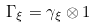<formula> <loc_0><loc_0><loc_500><loc_500>\Gamma _ { \xi } = \gamma _ { \xi } \otimes 1</formula> 